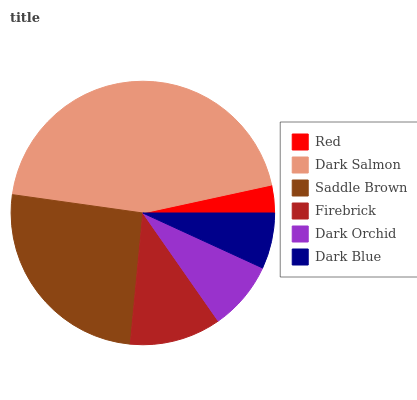Is Red the minimum?
Answer yes or no. Yes. Is Dark Salmon the maximum?
Answer yes or no. Yes. Is Saddle Brown the minimum?
Answer yes or no. No. Is Saddle Brown the maximum?
Answer yes or no. No. Is Dark Salmon greater than Saddle Brown?
Answer yes or no. Yes. Is Saddle Brown less than Dark Salmon?
Answer yes or no. Yes. Is Saddle Brown greater than Dark Salmon?
Answer yes or no. No. Is Dark Salmon less than Saddle Brown?
Answer yes or no. No. Is Firebrick the high median?
Answer yes or no. Yes. Is Dark Orchid the low median?
Answer yes or no. Yes. Is Dark Orchid the high median?
Answer yes or no. No. Is Red the low median?
Answer yes or no. No. 